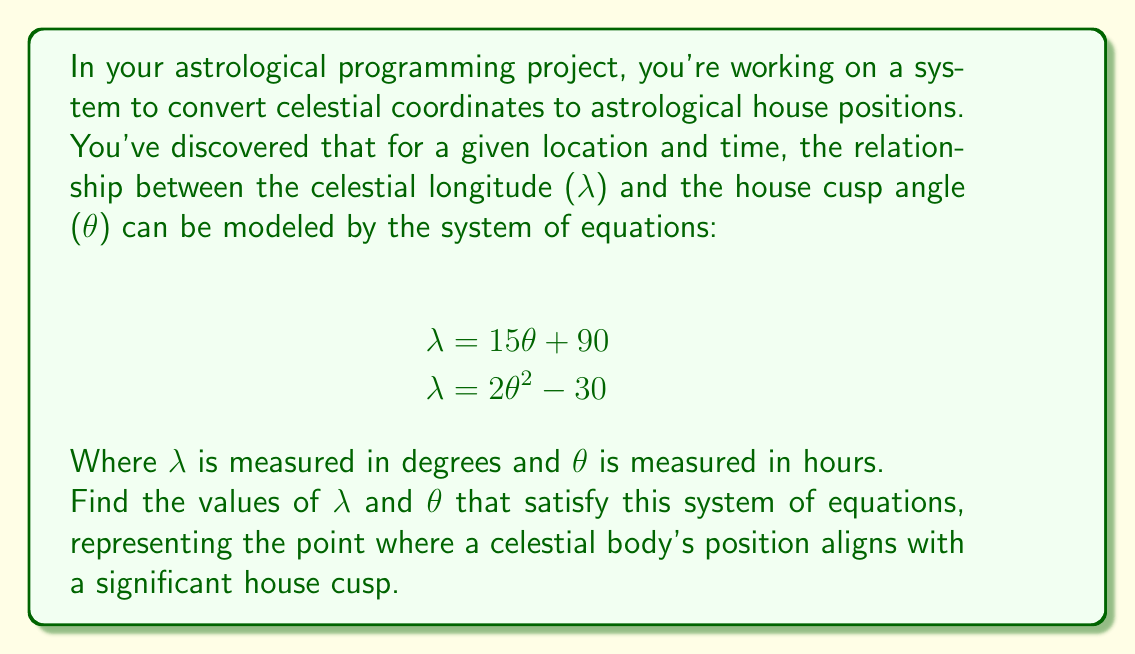Teach me how to tackle this problem. Let's approach this step-by-step:

1) We have two equations:
   $$\begin{align}
   \lambda &= 15\theta + 90 \tag{1} \\
   \lambda &= 2\theta^2 - 30 \tag{2}
   \end{align}$$

2) Since both equations are equal to $\lambda$, we can set them equal to each other:
   $$15\theta + 90 = 2\theta^2 - 30$$

3) Rearrange the equation:
   $$2\theta^2 - 15\theta - 120 = 0$$

4) This is a quadratic equation. We can solve it using the quadratic formula:
   $$\theta = \frac{-b \pm \sqrt{b^2 - 4ac}}{2a}$$
   Where $a = 2$, $b = -15$, and $c = -120$

5) Plugging in these values:
   $$\theta = \frac{15 \pm \sqrt{(-15)^2 - 4(2)(-120)}}{2(2)}$$
   $$= \frac{15 \pm \sqrt{225 + 960}}{4}$$
   $$= \frac{15 \pm \sqrt{1185}}{4}$$
   $$= \frac{15 \pm 34.42}{4}$$

6) This gives us two solutions:
   $$\theta_1 = \frac{15 + 34.42}{4} = 12.36 \text{ hours}$$
   $$\theta_2 = \frac{15 - 34.42}{4} = -4.86 \text{ hours}$$

7) Since $\theta$ represents hours, the negative solution doesn't make sense in this context. So we'll use $\theta = 12.36$ hours.

8) To find $\lambda$, we can plug this value of $\theta$ into either of our original equations. Let's use equation (1):
   $$\lambda = 15(12.36) + 90 = 275.4^\circ$$

Therefore, the solution is $\theta = 12.36$ hours and $\lambda = 275.4^\circ$.
Answer: $\theta = 12.36$ hours, $\lambda = 275.4^\circ$ 